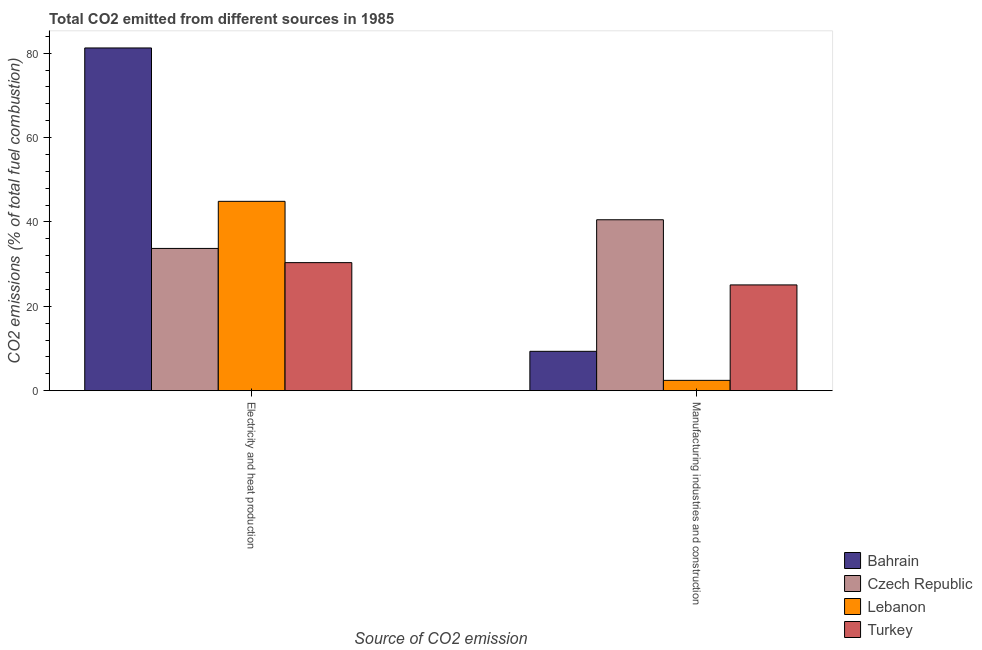How many different coloured bars are there?
Make the answer very short. 4. How many bars are there on the 1st tick from the right?
Keep it short and to the point. 4. What is the label of the 1st group of bars from the left?
Your response must be concise. Electricity and heat production. What is the co2 emissions due to electricity and heat production in Lebanon?
Offer a terse response. 44.89. Across all countries, what is the maximum co2 emissions due to manufacturing industries?
Offer a very short reply. 40.52. Across all countries, what is the minimum co2 emissions due to manufacturing industries?
Offer a very short reply. 2.44. In which country was the co2 emissions due to electricity and heat production maximum?
Make the answer very short. Bahrain. In which country was the co2 emissions due to electricity and heat production minimum?
Provide a succinct answer. Turkey. What is the total co2 emissions due to electricity and heat production in the graph?
Keep it short and to the point. 190.21. What is the difference between the co2 emissions due to manufacturing industries in Czech Republic and that in Bahrain?
Keep it short and to the point. 31.19. What is the difference between the co2 emissions due to manufacturing industries in Lebanon and the co2 emissions due to electricity and heat production in Turkey?
Your answer should be compact. -27.91. What is the average co2 emissions due to manufacturing industries per country?
Keep it short and to the point. 19.34. What is the difference between the co2 emissions due to electricity and heat production and co2 emissions due to manufacturing industries in Bahrain?
Make the answer very short. 71.92. In how many countries, is the co2 emissions due to manufacturing industries greater than 12 %?
Offer a terse response. 2. What is the ratio of the co2 emissions due to electricity and heat production in Bahrain to that in Lebanon?
Your answer should be compact. 1.81. Is the co2 emissions due to manufacturing industries in Turkey less than that in Czech Republic?
Your answer should be very brief. Yes. What does the 1st bar from the left in Manufacturing industries and construction represents?
Provide a short and direct response. Bahrain. What does the 2nd bar from the right in Manufacturing industries and construction represents?
Give a very brief answer. Lebanon. Are all the bars in the graph horizontal?
Make the answer very short. No. How many countries are there in the graph?
Keep it short and to the point. 4. Does the graph contain any zero values?
Make the answer very short. No. How many legend labels are there?
Provide a succinct answer. 4. How are the legend labels stacked?
Provide a succinct answer. Vertical. What is the title of the graph?
Make the answer very short. Total CO2 emitted from different sources in 1985. What is the label or title of the X-axis?
Give a very brief answer. Source of CO2 emission. What is the label or title of the Y-axis?
Your answer should be very brief. CO2 emissions (% of total fuel combustion). What is the CO2 emissions (% of total fuel combustion) in Bahrain in Electricity and heat production?
Keep it short and to the point. 81.25. What is the CO2 emissions (% of total fuel combustion) in Czech Republic in Electricity and heat production?
Your answer should be compact. 33.72. What is the CO2 emissions (% of total fuel combustion) of Lebanon in Electricity and heat production?
Make the answer very short. 44.89. What is the CO2 emissions (% of total fuel combustion) of Turkey in Electricity and heat production?
Offer a terse response. 30.35. What is the CO2 emissions (% of total fuel combustion) of Bahrain in Manufacturing industries and construction?
Provide a succinct answer. 9.33. What is the CO2 emissions (% of total fuel combustion) in Czech Republic in Manufacturing industries and construction?
Give a very brief answer. 40.52. What is the CO2 emissions (% of total fuel combustion) of Lebanon in Manufacturing industries and construction?
Your response must be concise. 2.44. What is the CO2 emissions (% of total fuel combustion) of Turkey in Manufacturing industries and construction?
Offer a very short reply. 25.07. Across all Source of CO2 emission, what is the maximum CO2 emissions (% of total fuel combustion) in Bahrain?
Your answer should be compact. 81.25. Across all Source of CO2 emission, what is the maximum CO2 emissions (% of total fuel combustion) of Czech Republic?
Offer a terse response. 40.52. Across all Source of CO2 emission, what is the maximum CO2 emissions (% of total fuel combustion) in Lebanon?
Provide a short and direct response. 44.89. Across all Source of CO2 emission, what is the maximum CO2 emissions (% of total fuel combustion) of Turkey?
Provide a succinct answer. 30.35. Across all Source of CO2 emission, what is the minimum CO2 emissions (% of total fuel combustion) of Bahrain?
Ensure brevity in your answer.  9.33. Across all Source of CO2 emission, what is the minimum CO2 emissions (% of total fuel combustion) of Czech Republic?
Your response must be concise. 33.72. Across all Source of CO2 emission, what is the minimum CO2 emissions (% of total fuel combustion) of Lebanon?
Provide a succinct answer. 2.44. Across all Source of CO2 emission, what is the minimum CO2 emissions (% of total fuel combustion) in Turkey?
Offer a very short reply. 25.07. What is the total CO2 emissions (% of total fuel combustion) of Bahrain in the graph?
Your answer should be very brief. 90.58. What is the total CO2 emissions (% of total fuel combustion) of Czech Republic in the graph?
Keep it short and to the point. 74.23. What is the total CO2 emissions (% of total fuel combustion) of Lebanon in the graph?
Keep it short and to the point. 47.33. What is the total CO2 emissions (% of total fuel combustion) of Turkey in the graph?
Ensure brevity in your answer.  55.42. What is the difference between the CO2 emissions (% of total fuel combustion) in Bahrain in Electricity and heat production and that in Manufacturing industries and construction?
Offer a very short reply. 71.92. What is the difference between the CO2 emissions (% of total fuel combustion) in Czech Republic in Electricity and heat production and that in Manufacturing industries and construction?
Provide a short and direct response. -6.8. What is the difference between the CO2 emissions (% of total fuel combustion) of Lebanon in Electricity and heat production and that in Manufacturing industries and construction?
Make the answer very short. 42.44. What is the difference between the CO2 emissions (% of total fuel combustion) in Turkey in Electricity and heat production and that in Manufacturing industries and construction?
Offer a very short reply. 5.28. What is the difference between the CO2 emissions (% of total fuel combustion) of Bahrain in Electricity and heat production and the CO2 emissions (% of total fuel combustion) of Czech Republic in Manufacturing industries and construction?
Offer a terse response. 40.73. What is the difference between the CO2 emissions (% of total fuel combustion) of Bahrain in Electricity and heat production and the CO2 emissions (% of total fuel combustion) of Lebanon in Manufacturing industries and construction?
Offer a terse response. 78.81. What is the difference between the CO2 emissions (% of total fuel combustion) in Bahrain in Electricity and heat production and the CO2 emissions (% of total fuel combustion) in Turkey in Manufacturing industries and construction?
Offer a terse response. 56.18. What is the difference between the CO2 emissions (% of total fuel combustion) in Czech Republic in Electricity and heat production and the CO2 emissions (% of total fuel combustion) in Lebanon in Manufacturing industries and construction?
Your response must be concise. 31.28. What is the difference between the CO2 emissions (% of total fuel combustion) of Czech Republic in Electricity and heat production and the CO2 emissions (% of total fuel combustion) of Turkey in Manufacturing industries and construction?
Your response must be concise. 8.65. What is the difference between the CO2 emissions (% of total fuel combustion) in Lebanon in Electricity and heat production and the CO2 emissions (% of total fuel combustion) in Turkey in Manufacturing industries and construction?
Offer a very short reply. 19.82. What is the average CO2 emissions (% of total fuel combustion) in Bahrain per Source of CO2 emission?
Provide a succinct answer. 45.29. What is the average CO2 emissions (% of total fuel combustion) of Czech Republic per Source of CO2 emission?
Provide a short and direct response. 37.12. What is the average CO2 emissions (% of total fuel combustion) in Lebanon per Source of CO2 emission?
Your response must be concise. 23.66. What is the average CO2 emissions (% of total fuel combustion) of Turkey per Source of CO2 emission?
Your answer should be very brief. 27.71. What is the difference between the CO2 emissions (% of total fuel combustion) in Bahrain and CO2 emissions (% of total fuel combustion) in Czech Republic in Electricity and heat production?
Offer a very short reply. 47.53. What is the difference between the CO2 emissions (% of total fuel combustion) in Bahrain and CO2 emissions (% of total fuel combustion) in Lebanon in Electricity and heat production?
Your answer should be compact. 36.36. What is the difference between the CO2 emissions (% of total fuel combustion) in Bahrain and CO2 emissions (% of total fuel combustion) in Turkey in Electricity and heat production?
Offer a terse response. 50.9. What is the difference between the CO2 emissions (% of total fuel combustion) in Czech Republic and CO2 emissions (% of total fuel combustion) in Lebanon in Electricity and heat production?
Offer a terse response. -11.17. What is the difference between the CO2 emissions (% of total fuel combustion) in Czech Republic and CO2 emissions (% of total fuel combustion) in Turkey in Electricity and heat production?
Your answer should be very brief. 3.37. What is the difference between the CO2 emissions (% of total fuel combustion) of Lebanon and CO2 emissions (% of total fuel combustion) of Turkey in Electricity and heat production?
Your answer should be very brief. 14.53. What is the difference between the CO2 emissions (% of total fuel combustion) in Bahrain and CO2 emissions (% of total fuel combustion) in Czech Republic in Manufacturing industries and construction?
Your answer should be compact. -31.19. What is the difference between the CO2 emissions (% of total fuel combustion) of Bahrain and CO2 emissions (% of total fuel combustion) of Lebanon in Manufacturing industries and construction?
Your answer should be very brief. 6.88. What is the difference between the CO2 emissions (% of total fuel combustion) of Bahrain and CO2 emissions (% of total fuel combustion) of Turkey in Manufacturing industries and construction?
Make the answer very short. -15.74. What is the difference between the CO2 emissions (% of total fuel combustion) in Czech Republic and CO2 emissions (% of total fuel combustion) in Lebanon in Manufacturing industries and construction?
Offer a very short reply. 38.07. What is the difference between the CO2 emissions (% of total fuel combustion) in Czech Republic and CO2 emissions (% of total fuel combustion) in Turkey in Manufacturing industries and construction?
Give a very brief answer. 15.45. What is the difference between the CO2 emissions (% of total fuel combustion) in Lebanon and CO2 emissions (% of total fuel combustion) in Turkey in Manufacturing industries and construction?
Your response must be concise. -22.63. What is the ratio of the CO2 emissions (% of total fuel combustion) in Bahrain in Electricity and heat production to that in Manufacturing industries and construction?
Your answer should be compact. 8.71. What is the ratio of the CO2 emissions (% of total fuel combustion) of Czech Republic in Electricity and heat production to that in Manufacturing industries and construction?
Offer a terse response. 0.83. What is the ratio of the CO2 emissions (% of total fuel combustion) in Lebanon in Electricity and heat production to that in Manufacturing industries and construction?
Provide a succinct answer. 18.38. What is the ratio of the CO2 emissions (% of total fuel combustion) in Turkey in Electricity and heat production to that in Manufacturing industries and construction?
Your response must be concise. 1.21. What is the difference between the highest and the second highest CO2 emissions (% of total fuel combustion) in Bahrain?
Your response must be concise. 71.92. What is the difference between the highest and the second highest CO2 emissions (% of total fuel combustion) of Czech Republic?
Your answer should be very brief. 6.8. What is the difference between the highest and the second highest CO2 emissions (% of total fuel combustion) of Lebanon?
Offer a very short reply. 42.44. What is the difference between the highest and the second highest CO2 emissions (% of total fuel combustion) in Turkey?
Your answer should be compact. 5.28. What is the difference between the highest and the lowest CO2 emissions (% of total fuel combustion) of Bahrain?
Your response must be concise. 71.92. What is the difference between the highest and the lowest CO2 emissions (% of total fuel combustion) of Czech Republic?
Provide a short and direct response. 6.8. What is the difference between the highest and the lowest CO2 emissions (% of total fuel combustion) of Lebanon?
Make the answer very short. 42.44. What is the difference between the highest and the lowest CO2 emissions (% of total fuel combustion) of Turkey?
Offer a very short reply. 5.28. 